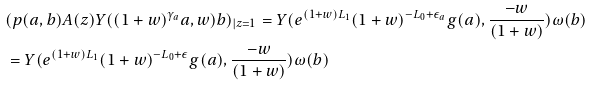Convert formula to latex. <formula><loc_0><loc_0><loc_500><loc_500>& ( p ( a , b ) A ( z ) Y ( ( 1 + w ) ^ { \gamma _ { a } } a , w ) b ) _ { | z = 1 } = Y ( e ^ { ( 1 + w ) L _ { 1 } } ( 1 + w ) ^ { - L _ { 0 } + \epsilon _ { a } } g ( a ) , \frac { - w } { ( 1 + w ) } ) \omega ( b ) \\ & = Y ( e ^ { ( 1 + w ) L _ { 1 } } ( 1 + w ) ^ { - L _ { 0 } + \epsilon } g ( a ) , \frac { - w } { ( 1 + w ) } ) \omega ( b )</formula> 